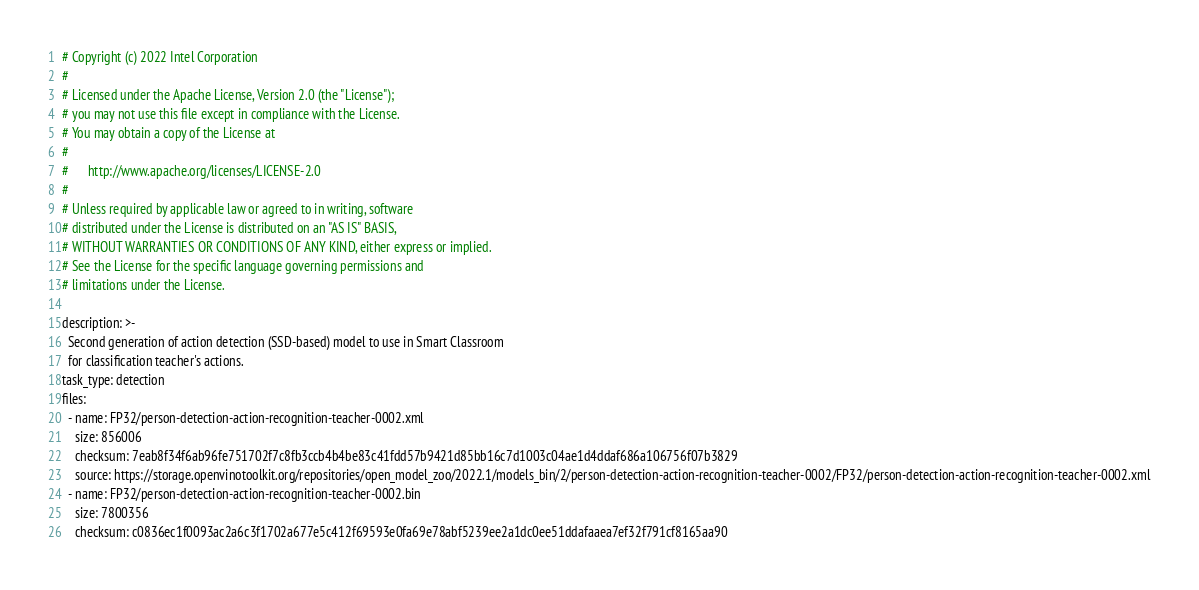<code> <loc_0><loc_0><loc_500><loc_500><_YAML_># Copyright (c) 2022 Intel Corporation
#
# Licensed under the Apache License, Version 2.0 (the "License");
# you may not use this file except in compliance with the License.
# You may obtain a copy of the License at
#
#      http://www.apache.org/licenses/LICENSE-2.0
#
# Unless required by applicable law or agreed to in writing, software
# distributed under the License is distributed on an "AS IS" BASIS,
# WITHOUT WARRANTIES OR CONDITIONS OF ANY KIND, either express or implied.
# See the License for the specific language governing permissions and
# limitations under the License.

description: >-
  Second generation of action detection (SSD-based) model to use in Smart Classroom
  for classification teacher's actions.
task_type: detection
files:
  - name: FP32/person-detection-action-recognition-teacher-0002.xml
    size: 856006
    checksum: 7eab8f34f6ab96fe751702f7c8fb3ccb4b4be83c41fdd57b9421d85bb16c7d1003c04ae1d4ddaf686a106756f07b3829
    source: https://storage.openvinotoolkit.org/repositories/open_model_zoo/2022.1/models_bin/2/person-detection-action-recognition-teacher-0002/FP32/person-detection-action-recognition-teacher-0002.xml
  - name: FP32/person-detection-action-recognition-teacher-0002.bin
    size: 7800356
    checksum: c0836ec1f0093ac2a6c3f1702a677e5c412f69593e0fa69e78abf5239ee2a1dc0ee51ddafaaea7ef32f791cf8165aa90</code> 